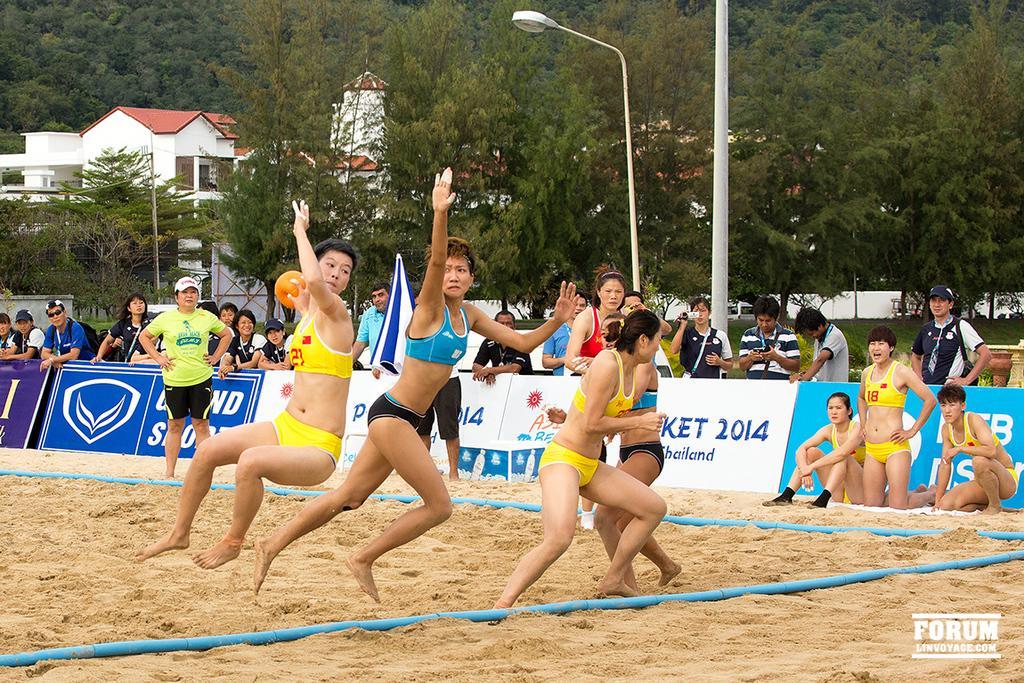Can you describe this image briefly? In the image we can see there are people standing on the ground and playing with ball. The ground is covered with sand and there is a fencing kept on the ground which is a blue colour rope. There are spectators standing on the road and few people are holding video camera in their hand. Behind there are lot of trees and there is a building. 